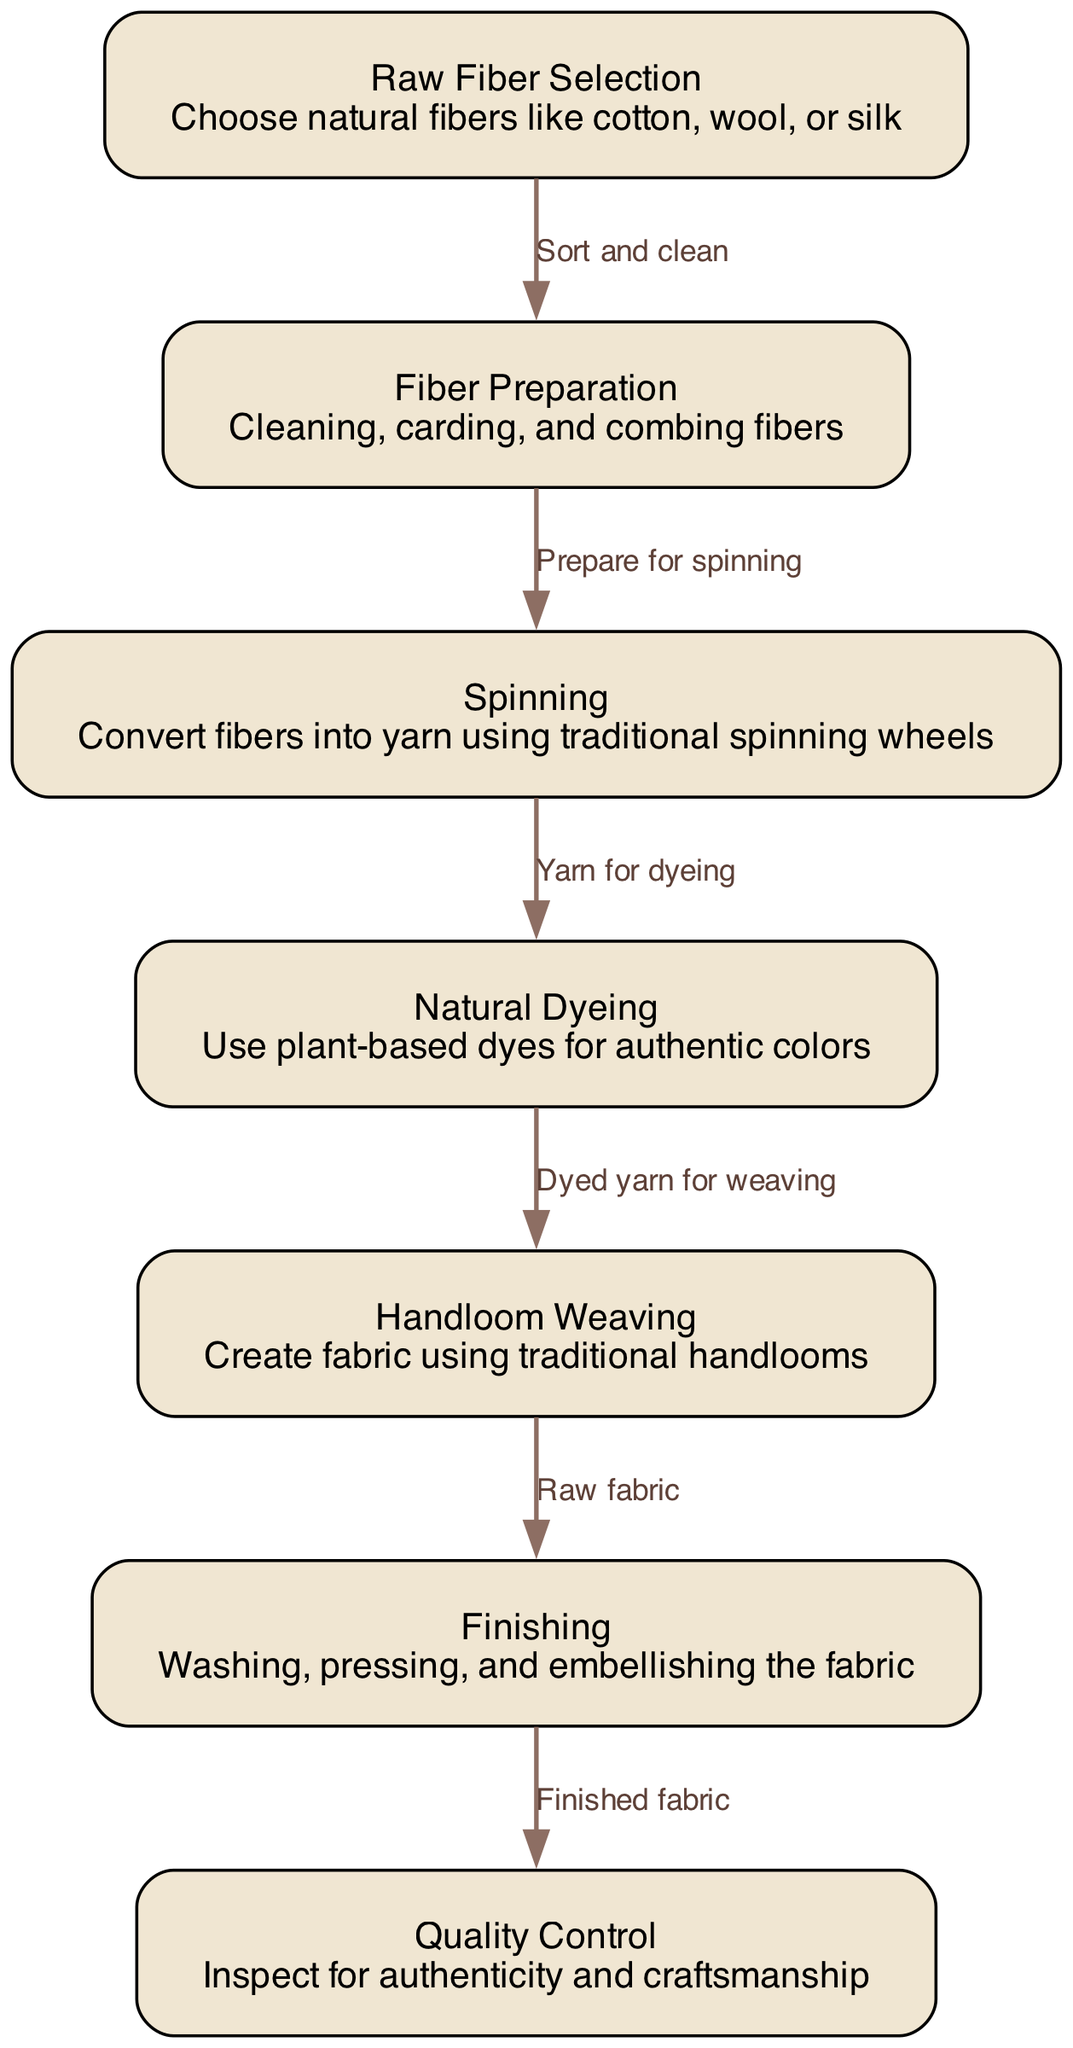What is the first step in the textile manufacturing process? The diagram presents "Raw Fiber Selection" as the initial node, indicating it is the starting point of the textile manufacturing process.
Answer: Raw Fiber Selection How many nodes are present in the diagram? The diagram consists of 7 nodes, as each unique process in the textile manufacturing flow corresponds to a node.
Answer: 7 What is the relationship between "Fiber Preparation" and "Spinning"? "Fiber Preparation" connects to "Spinning" with the edge labeled "Prepare for spinning," showing that preparation is essential before the spinning process.
Answer: Prepare for spinning Which process follows "Natural Dyeing"? The next node after "Natural Dyeing," as indicated by the directional edge, is "Handloom Weaving." This progression signifies that dyed yarn is used for weaving fabric.
Answer: Handloom Weaving What inspection occurs after the Finishing process? After the "Finishing" step in the manufacturing process, there is a Quality Control inspection, which checks the fabric for authenticity and craftsmanship, as shown by the subsequent node connection.
Answer: Quality Control What type of dye is utilized during the dyeing process? The diagram specifies that "Natural Dyeing" uses "plant-based dyes," highlighting the emphasis on authenticity in the coloration of traditional fabrics.
Answer: Plant-based dyes What is produced after "Handloom Weaving"? The process that immediately follows "Handloom Weaving" is "Finishing," indicating that raw fabric is the product that emerges from the weaving stage before any finishing touches are applied.
Answer: Finishing What is the main focus during Quality Control? The diagram states that Quality Control is concerned with inspecting for "authenticity and craftsmanship," which are critical elements in maintaining high standards in traditional fabric production.
Answer: Authenticity and craftsmanship What is the last step in the process flow? The final step in the textile manufacturing process, represented as the last node in the diagram, is "Quality Control," marking the completion of the fabric production flow before it is deemed finished.
Answer: Quality Control 